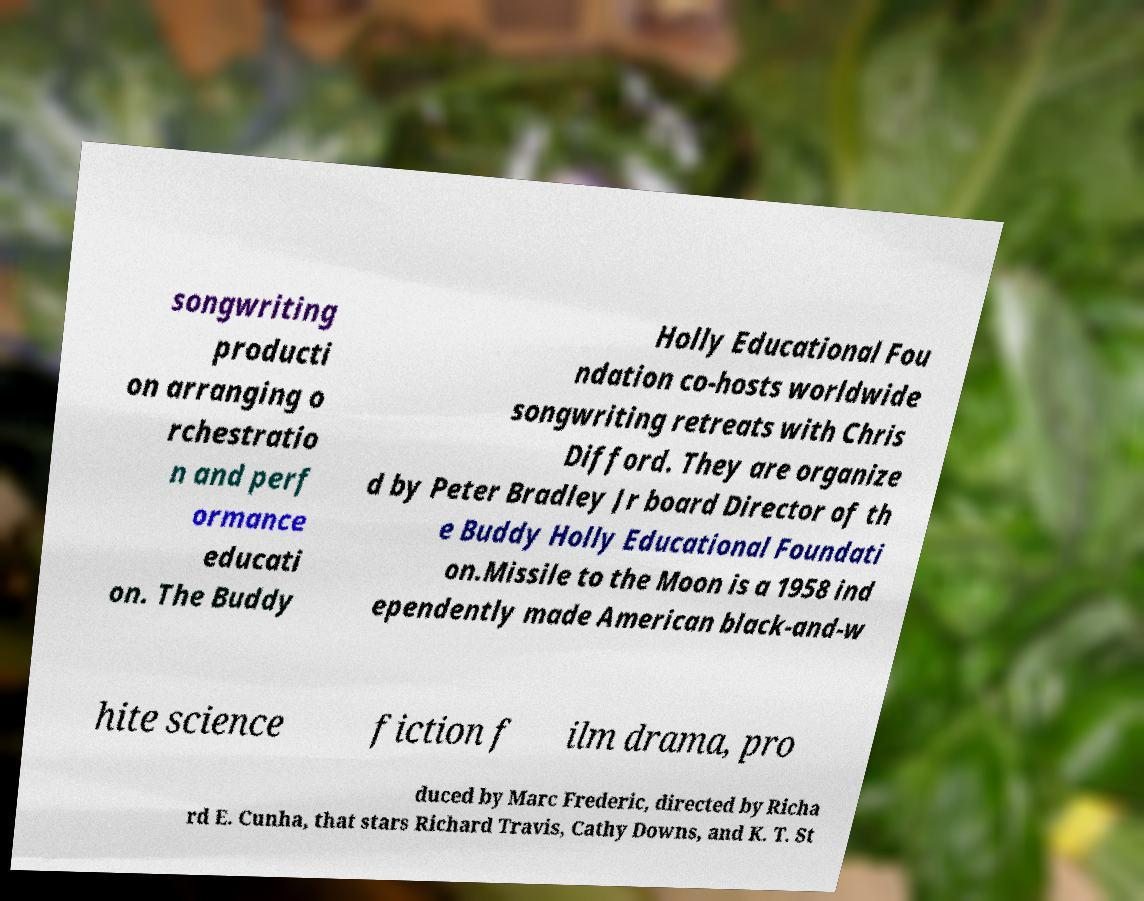Could you assist in decoding the text presented in this image and type it out clearly? songwriting producti on arranging o rchestratio n and perf ormance educati on. The Buddy Holly Educational Fou ndation co-hosts worldwide songwriting retreats with Chris Difford. They are organize d by Peter Bradley Jr board Director of th e Buddy Holly Educational Foundati on.Missile to the Moon is a 1958 ind ependently made American black-and-w hite science fiction f ilm drama, pro duced by Marc Frederic, directed by Richa rd E. Cunha, that stars Richard Travis, Cathy Downs, and K. T. St 